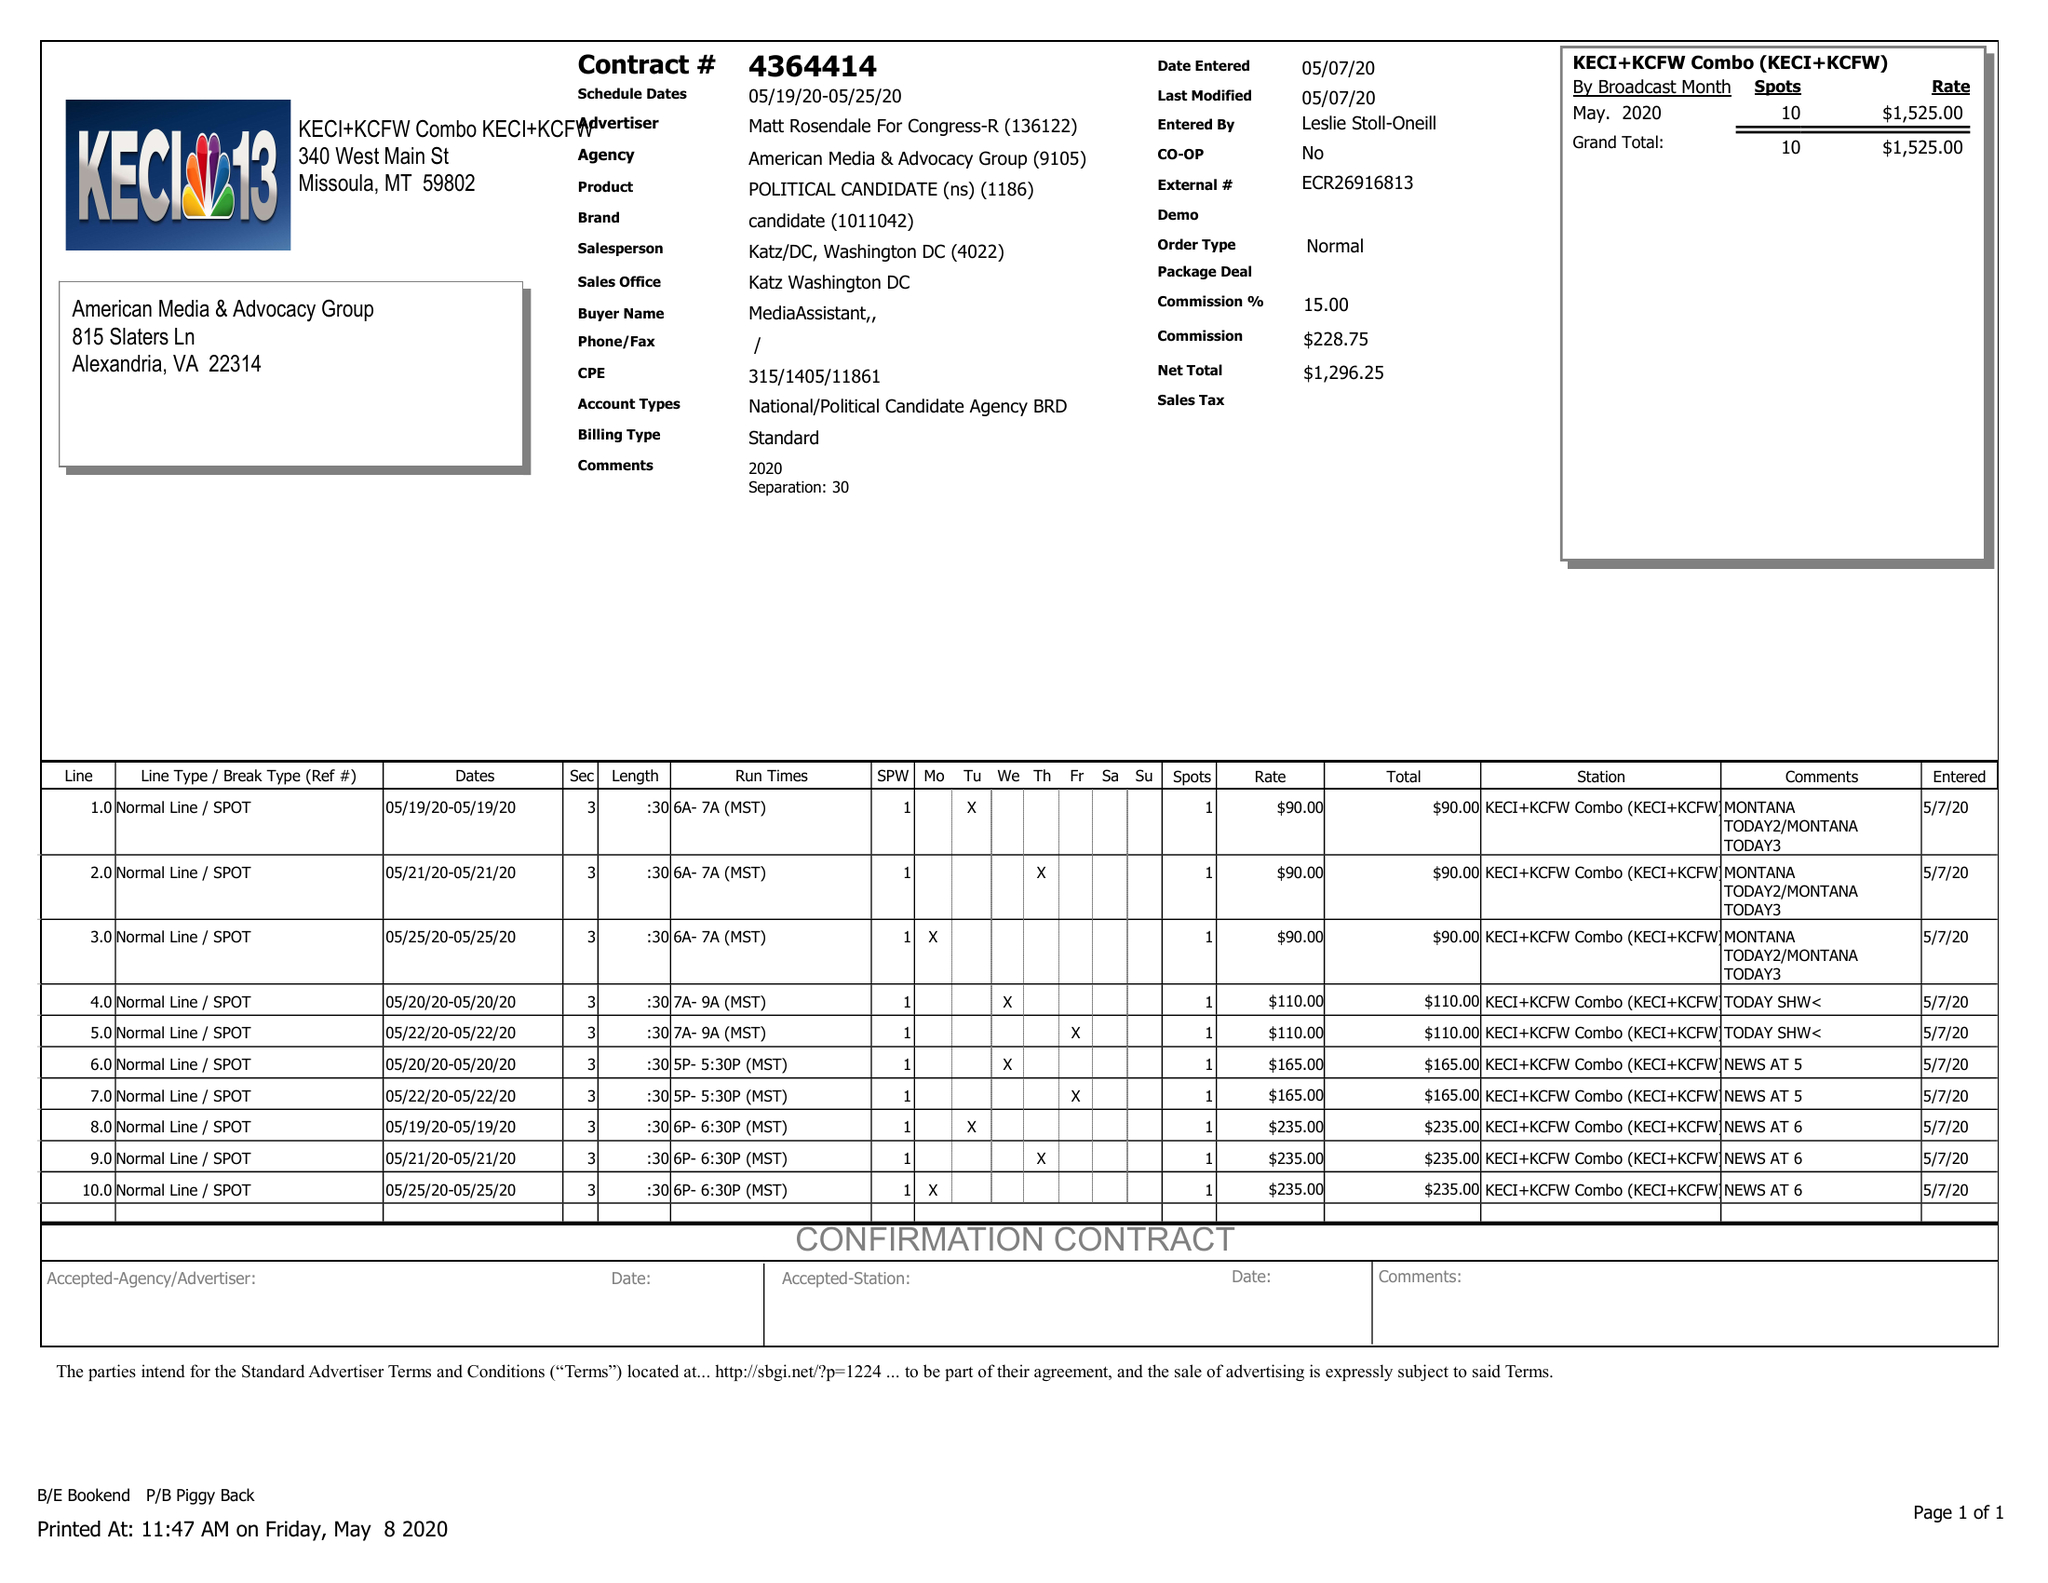What is the value for the flight_to?
Answer the question using a single word or phrase. 05/25/20 